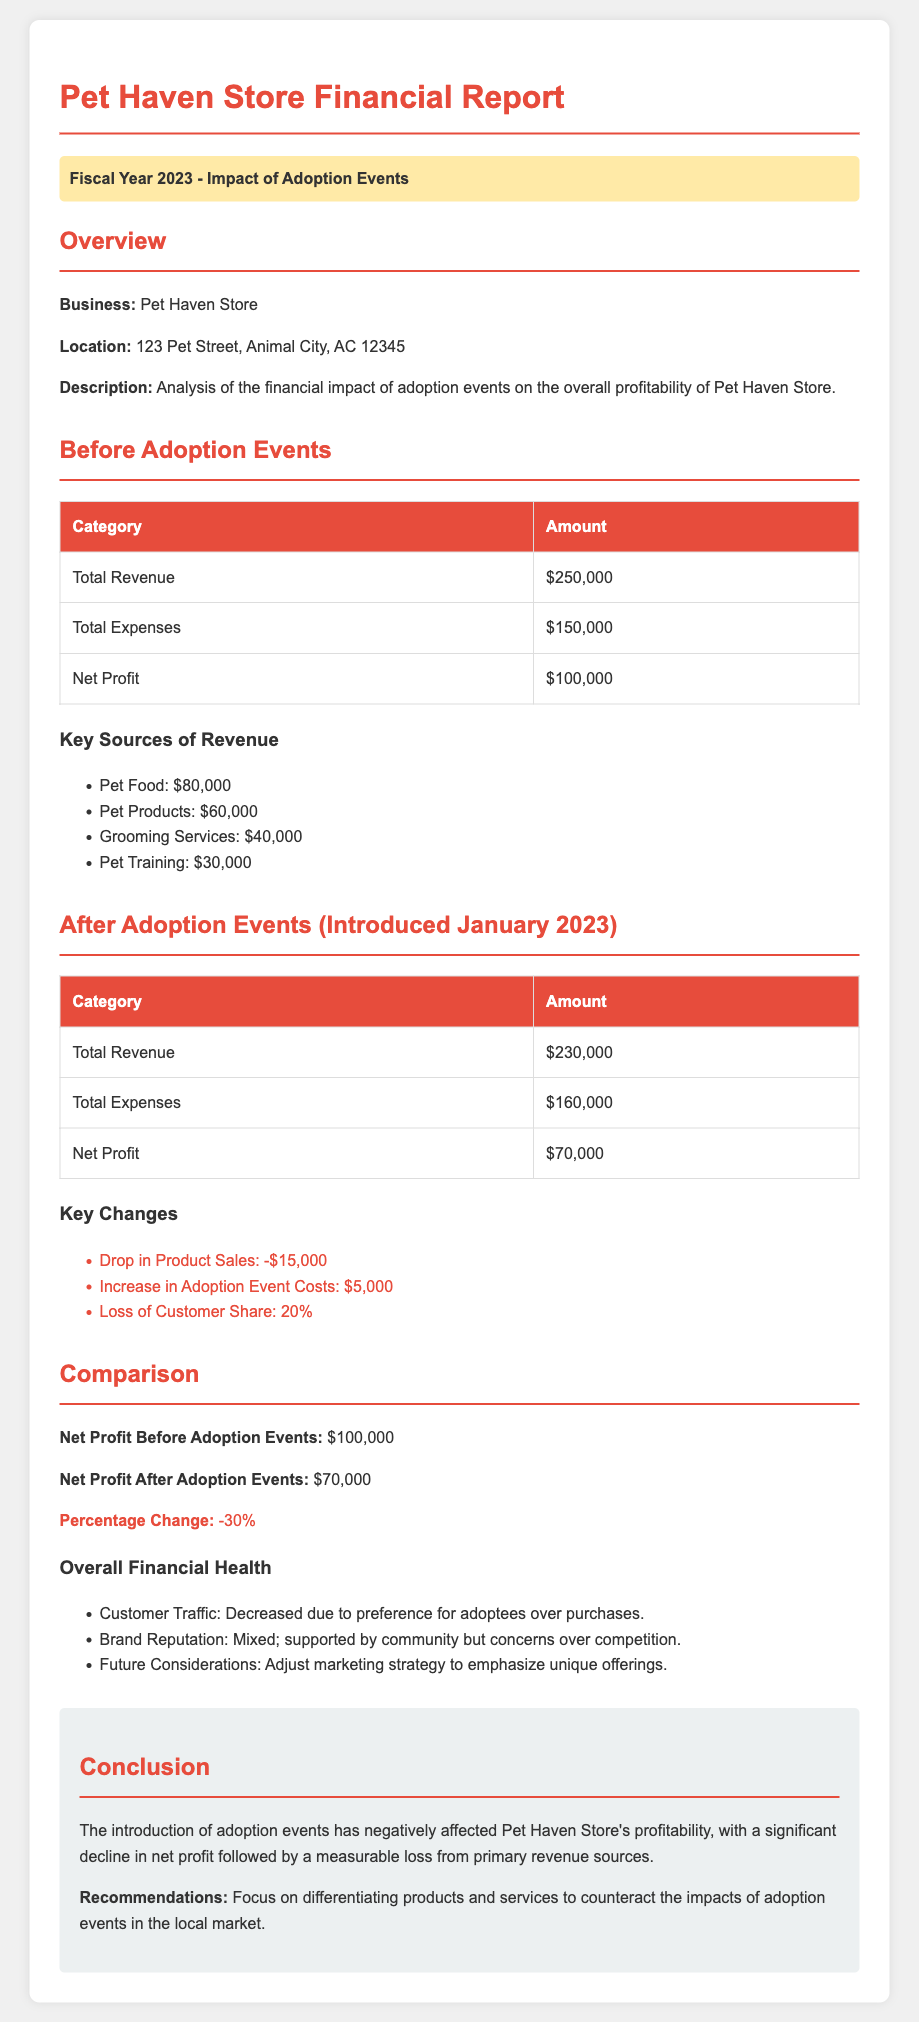What was the total revenue before adoption events? The total revenue before adoption events is stated in the document as $250,000.
Answer: $250,000 What was the net profit after adoption events? The net profit after adoption events is provided in the document as $70,000.
Answer: $70,000 What change in total revenue occurred after introducing adoption events? The document indicates a decrease in total revenue from $250,000 to $230,000, resulting in a drop of $20,000.
Answer: -$20,000 What percentage did the net profit decrease by after adoption events? The document mentions that the net profit decreased by 30% following the introduction of adoption events.
Answer: 30% What was the total expense after adoption events? The total expenses after adoption events are listed in the document as $160,000.
Answer: $160,000 What was the key source of revenue contributing the most before adoption events? The key source of revenue contributing the most before adoption events was Pet Food, showing $80,000.
Answer: Pet Food How did customer traffic change after adoption events? The document states that customer traffic decreased due to preference for adoptees over purchases.
Answer: Decreased What was the increase in costs related to adoption events? The document specifies that the increase in adoption event costs amounted to $5,000.
Answer: $5,000 What is the overall financial health in terms of brand reputation after the events? The document describes the brand reputation as mixed, supported by the community but with concerns over competition.
Answer: Mixed 